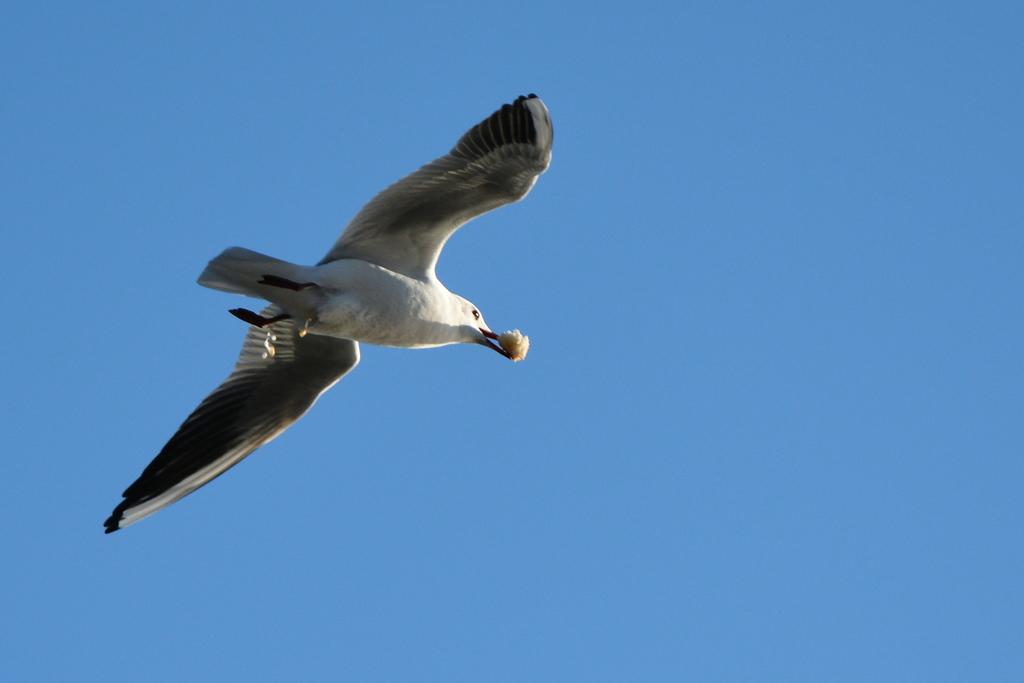What type of animal can be seen in the image? There is a bird in the image. What is the bird doing in the image? The bird is flying in the air. What is the bird holding in its mouth? The bird is holding a food item in its mouth. What can be seen in the background of the image? The sky is visible in the background of the image. What is the color of the sky in the image? The sky is blue in color. What type of cheese can be seen on the bird's back in the image? There is no cheese present on the bird's back in the image. 